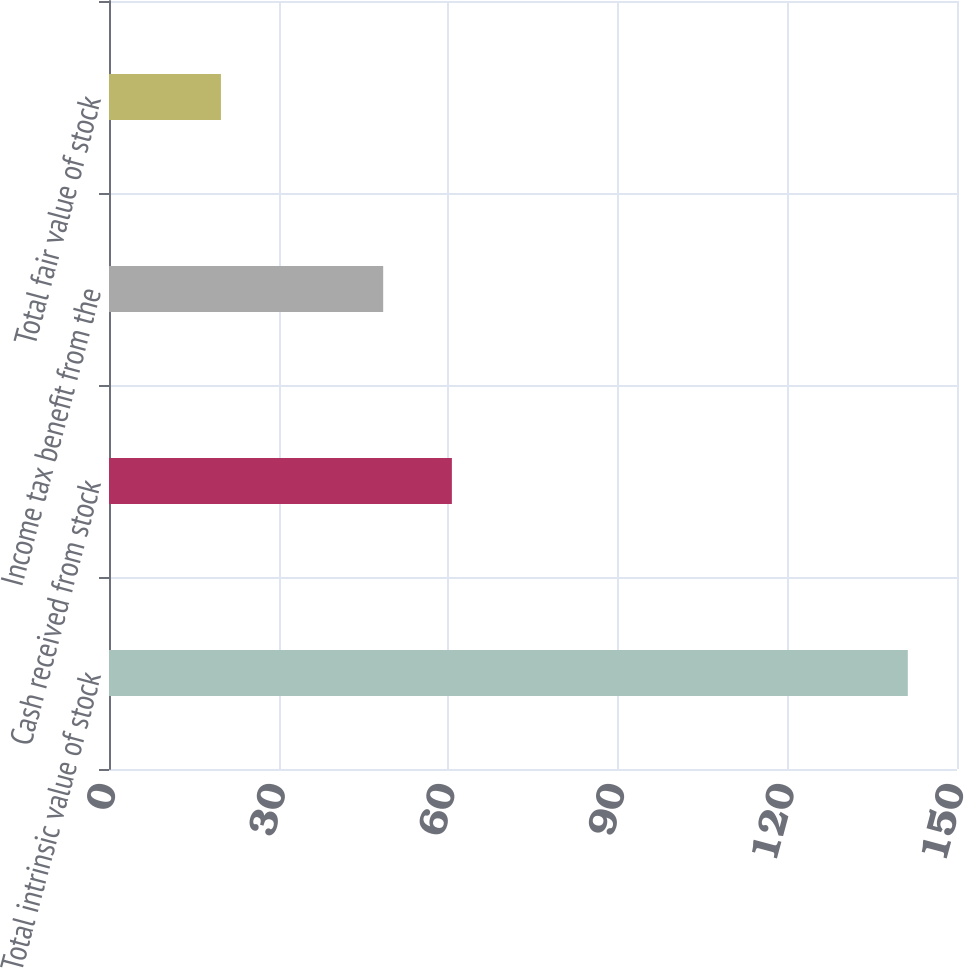Convert chart to OTSL. <chart><loc_0><loc_0><loc_500><loc_500><bar_chart><fcel>Total intrinsic value of stock<fcel>Cash received from stock<fcel>Income tax benefit from the<fcel>Total fair value of stock<nl><fcel>141.3<fcel>60.65<fcel>48.5<fcel>19.8<nl></chart> 